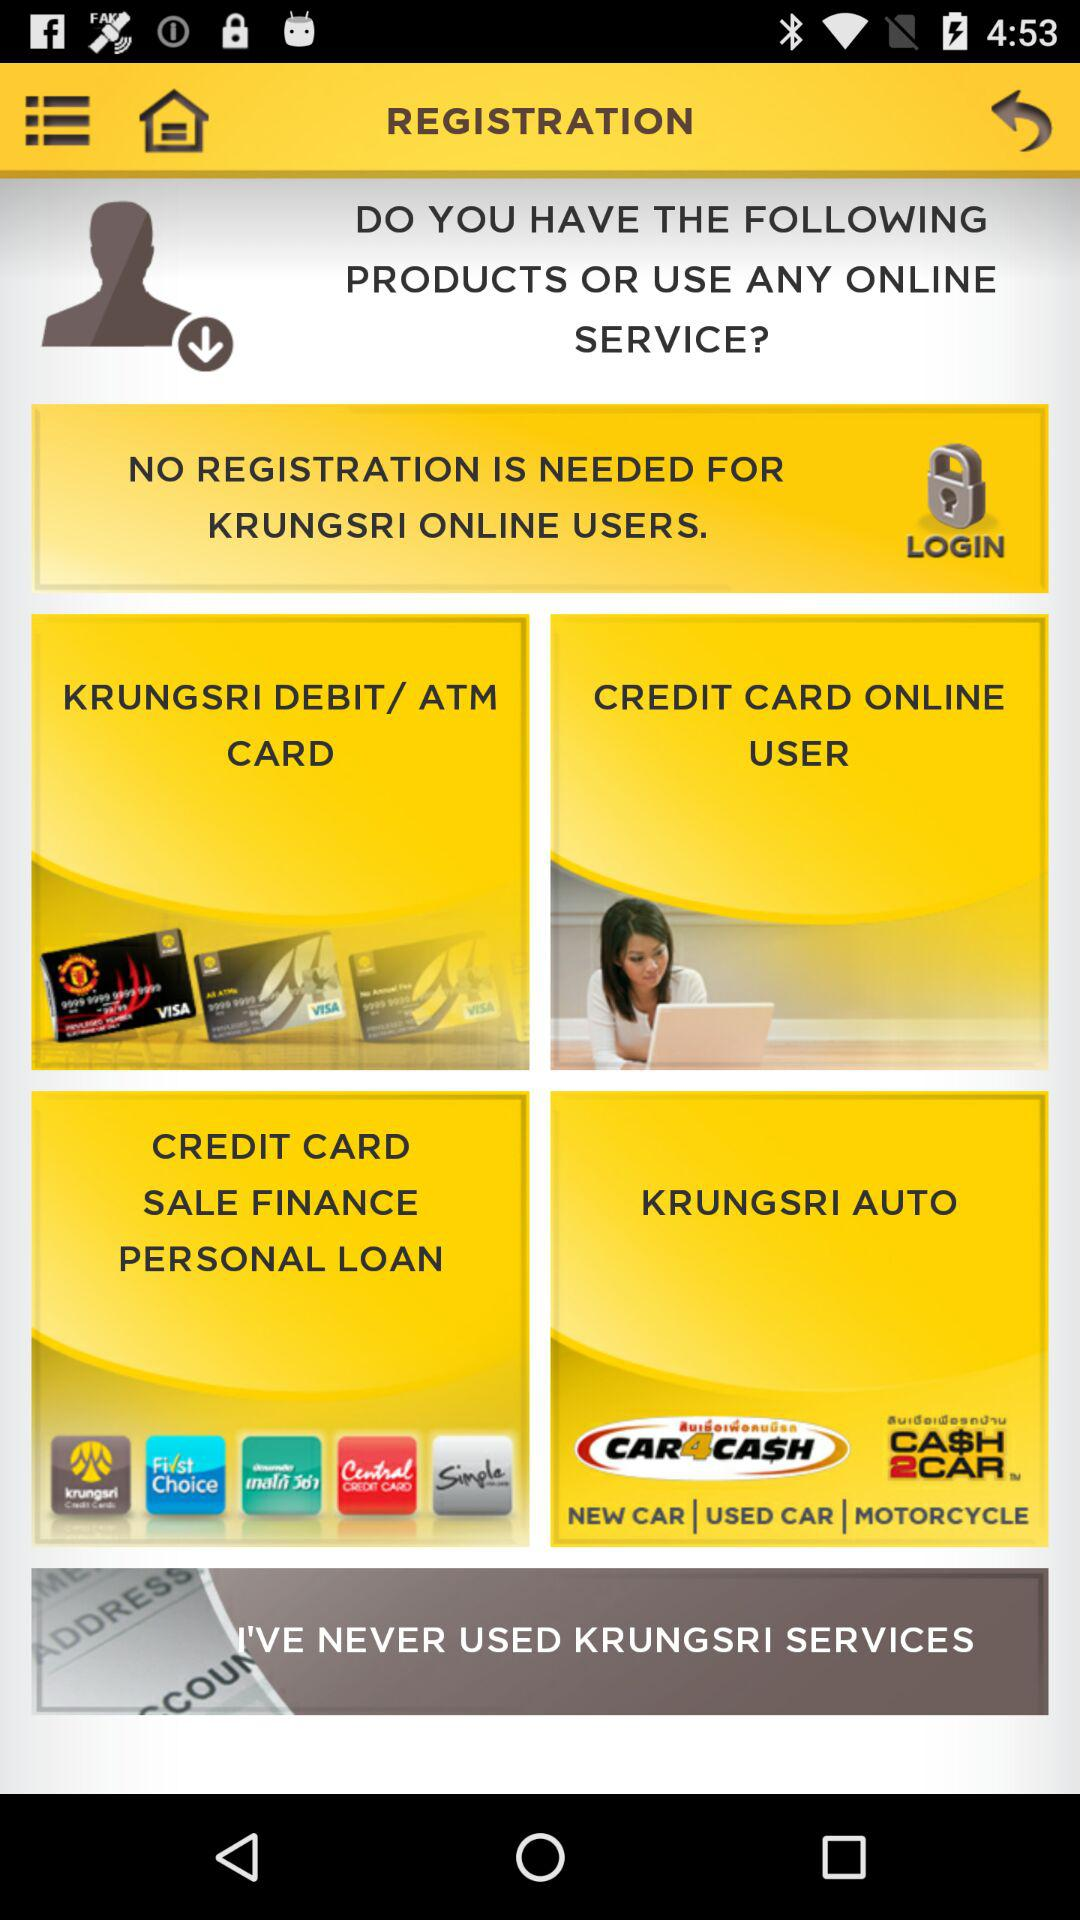What are the available online services? The available online services are "KRUNGSRI DEBIT/ ATM CARD", "CREDIT CARD ONLINE USER", "CREDIT CARD SALE FINANCE PERSONAL LOAN" and "KRUNGSRI AUTO". 